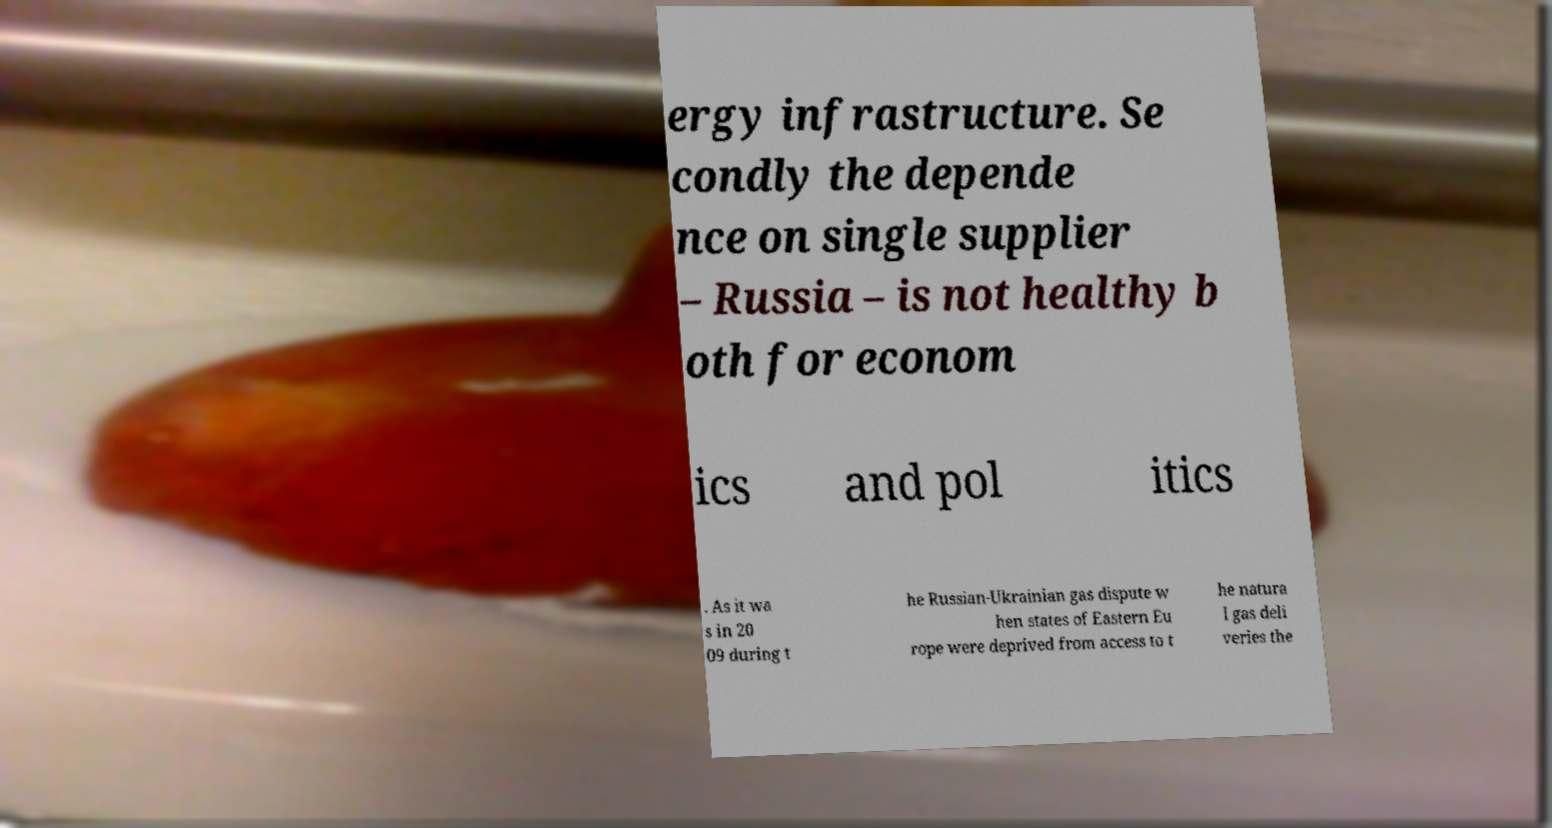Could you extract and type out the text from this image? ergy infrastructure. Se condly the depende nce on single supplier – Russia – is not healthy b oth for econom ics and pol itics . As it wa s in 20 09 during t he Russian-Ukrainian gas dispute w hen states of Eastern Eu rope were deprived from access to t he natura l gas deli veries the 